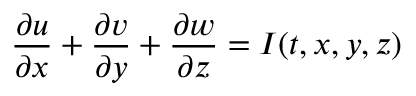Convert formula to latex. <formula><loc_0><loc_0><loc_500><loc_500>\frac { \partial u } { \partial x } + \frac { \partial v } { \partial y } + \frac { \partial w } { \partial z } = I ( t , x , y , z )</formula> 